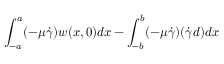Convert formula to latex. <formula><loc_0><loc_0><loc_500><loc_500>\int _ { - a } ^ { a } ( - \mu \dot { \gamma } ) w ( x , 0 ) d x - \int _ { - b } ^ { b } ( - \mu \dot { \gamma } ) ( \dot { \gamma } d ) d x</formula> 